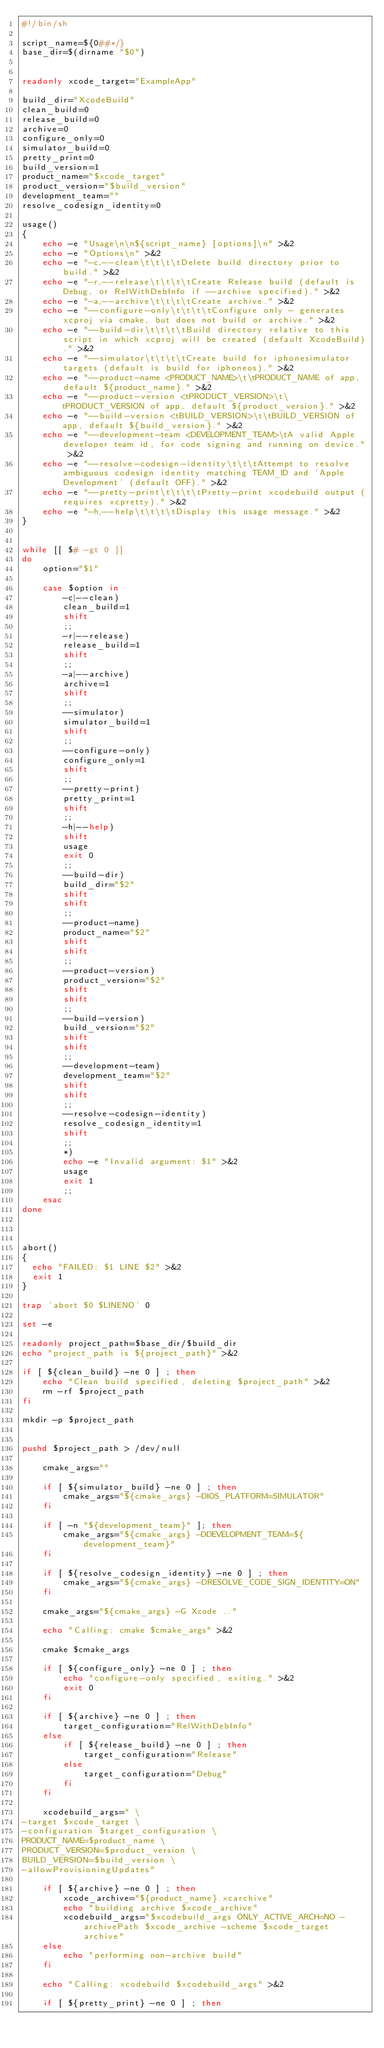<code> <loc_0><loc_0><loc_500><loc_500><_Bash_>#!/bin/sh

script_name=${0##*/}
base_dir=$(dirname "$0")


readonly xcode_target="ExampleApp"

build_dir="XcodeBuild"
clean_build=0
release_build=0
archive=0
configure_only=0
simulator_build=0
pretty_print=0
build_version=1
product_name="$xcode_target"
product_version="$build_version"
development_team=""
resolve_codesign_identity=0

usage()
{
    echo -e "Usage\n\n${script_name} [options]\n" >&2
    echo -e "Options\n" >&2
    echo -e "-c,--clean\t\t\t\tDelete build directory prior to build." >&2
    echo -e "-r,--release\t\t\t\tCreate Release build (default is Debug, or RelWithDebInfo if --archive specified)." >&2
    echo -e "-a,--archive\t\t\t\tCreate archive." >&2
    echo -e "--configure-only\t\t\t\tConfigure only - generates xcproj via cmake, but does not build or archive." >&2
    echo -e "--build-dir\t\t\t\tBuild directory relative to this script in which xcproj will be created (default XcodeBuild)." >&2
    echo -e "--simulator\t\t\t\tCreate build for iphonesimulator targets (default is build for iphoneos)." >&2
    echo -e "--product-name <PRODUCT_NAME>\t\tPRODUCT_NAME of app, default ${product_name}." >&2
    echo -e "--product-version <tPRODUCT_VERSION>\t\tPRODUCT_VERSION of app, default ${product_version}." >&2
    echo -e "--build-version <tBUILD_VERSION>\t\tBUILD_VERSION of app, default ${build_version}." >&2
    echo -e "--development-team <DEVELOPMENT_TEAM>\tA valid Apple developer team id, for code signing and running on device." >&2
    echo -e "--resolve-codesign-identity\t\t\tAttempt to resolve ambiguous codesign identity matching TEAM_ID and 'Apple Development' (default OFF)." >&2
    echo -e "--pretty-print\t\t\t\tPretty-print xcodebuild output (requires xcpretty)." >&2
    echo -e "-h,--help\t\t\t\tDisplay this usage message." >&2
}


while [[ $# -gt 0 ]]
do
    option="$1"

    case $option in
        -c|--clean)
        clean_build=1
        shift
        ;;
        -r|--release)
        release_build=1
        shift
        ;;
        -a|--archive)
        archive=1
        shift
        ;;
        --simulator)
        simulator_build=1
        shift
        ;;
        --configure-only)
        configure_only=1
        shift
        ;;
        --pretty-print)
        pretty_print=1
        shift
        ;;
        -h|--help)
        shift
        usage
        exit 0
        ;;
        --build-dir)
        build_dir="$2"
        shift
        shift
        ;;
        --product-name)
        product_name="$2"
        shift
        shift
        ;;
        --product-version)
        product_version="$2"
        shift
        shift
        ;;
        --build-version)
        build_version="$2"
        shift
        shift
        ;;
        --development-team)
        development_team="$2"
        shift
        shift
        ;;
        --resolve-codesign-identity)
        resolve_codesign_identity=1
        shift
        ;;
        *)
        echo -e "Invalid argument: $1" >&2
        usage
        exit 1
        ;;
    esac
done



abort()
{
  echo "FAILED: $1 LINE $2" >&2
  exit 1
}

trap 'abort $0 $LINENO' 0

set -e

readonly project_path=$base_dir/$build_dir
echo "project_path is ${project_path}" >&2

if [ ${clean_build} -ne 0 ] ; then
    echo "Clean build specified, deleting $project_path" >&2
    rm -rf $project_path
fi

mkdir -p $project_path


pushd $project_path > /dev/null

    cmake_args=""

    if [ ${simulator_build} -ne 0 ] ; then
        cmake_args="${cmake_args} -DIOS_PLATFORM=SIMULATOR"
    fi

    if [ -n "${development_team}" ]; then
        cmake_args="${cmake_args} -DDEVELOPMENT_TEAM=${development_team}"
    fi

    if [ ${resolve_codesign_identity} -ne 0 ] ; then
        cmake_args="${cmake_args} -DRESOLVE_CODE_SIGN_IDENTITY=ON"
    fi

    cmake_args="${cmake_args} -G Xcode .."

    echo "Calling: cmake $cmake_args" >&2

    cmake $cmake_args

    if [ ${configure_only} -ne 0 ] ; then
        echo "configure-only specified, exiting." >&2
        exit 0
    fi

    if [ ${archive} -ne 0 ] ; then
        target_configuration="RelWithDebInfo"
    else
        if [ ${release_build} -ne 0 ] ; then
            target_configuration="Release"
        else
            target_configuration="Debug"
        fi
    fi

    xcodebuild_args=" \
-target $xcode_target \
-configuration $target_configuration \
PRODUCT_NAME=$product_name \
PRODUCT_VERSION=$product_version \
BUILD_VERSION=$build_version \
-allowProvisioningUpdates"

    if [ ${archive} -ne 0 ] ; then
        xcode_archive="${product_name}.xcarchive"
        echo "building archive $xcode_archive"
        xcodebuild_args="$xcodebuild_args ONLY_ACTIVE_ARCH=NO -archivePath $xcode_archive -scheme $xcode_target archive"
    else
        echo "performing non-archive build"
    fi

    echo "Calling: xcodebuild $xcodebuild_args" >&2

    if [ ${pretty_print} -ne 0 ] ; then</code> 